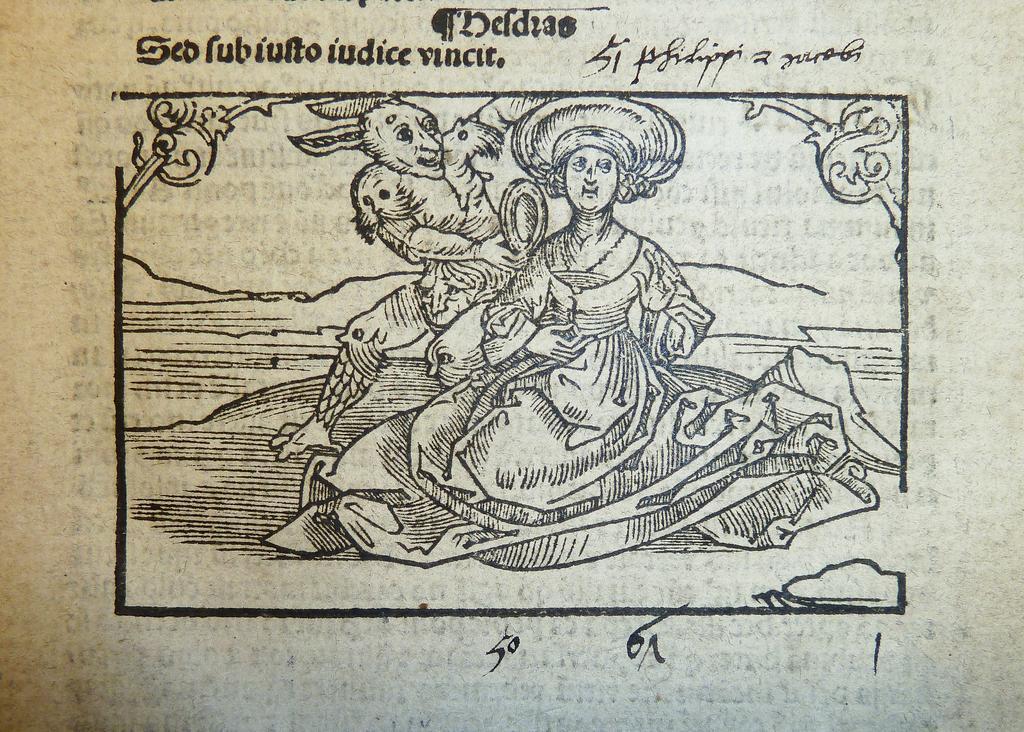Could you give a brief overview of what you see in this image? Here we can see a poster. On this poster we can see pictures and text written on it. 